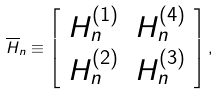Convert formula to latex. <formula><loc_0><loc_0><loc_500><loc_500>\overline { H } _ { n } \equiv \left [ \begin{array} { c c } H _ { n } ^ { ( 1 ) } & H _ { n } ^ { ( 4 ) } \\ H _ { n } ^ { ( 2 ) } & H _ { n } ^ { ( 3 ) } \end{array} \right ] ,</formula> 